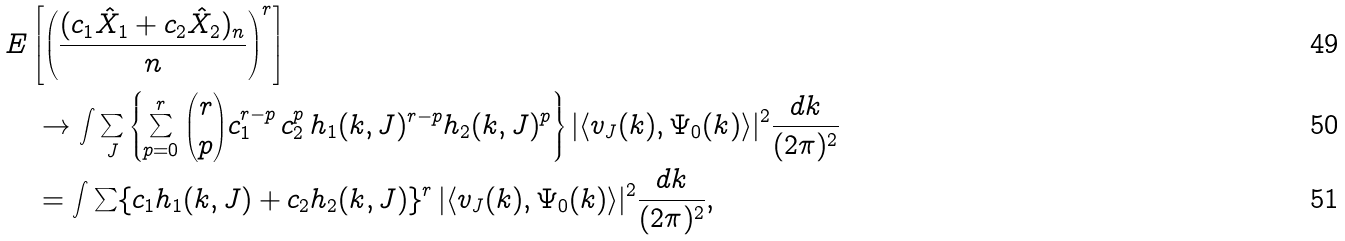<formula> <loc_0><loc_0><loc_500><loc_500>& E \left [ \left ( \frac { ( c _ { 1 } \hat { X } _ { 1 } + c _ { 2 } \hat { X } _ { 2 } ) _ { n } } { n } \right ) ^ { r } \right ] \\ & \quad \to \int \sum _ { J } \left \{ \sum _ { p = 0 } ^ { r } \binom { r } { p } c _ { 1 } ^ { r - p } \, c _ { 2 } ^ { p } \, h _ { 1 } ( { k } , J ) ^ { r - p } h _ { 2 } ( { k } , J ) ^ { p } \right \} | \langle v _ { J } ( { k } ) , \Psi _ { 0 } ( { k } ) \rangle | ^ { 2 } \frac { d { k } } { ( 2 \pi ) ^ { 2 } } \\ & \quad = \int \sum \{ c _ { 1 } h _ { 1 } ( { k } , J ) + c _ { 2 } h _ { 2 } ( { k } , J ) \} ^ { r } \, | \langle v _ { J } ( { k } ) , \Psi _ { 0 } ( { k } ) \rangle | ^ { 2 } \frac { d { k } } { ( 2 \pi ) ^ { 2 } } ,</formula> 